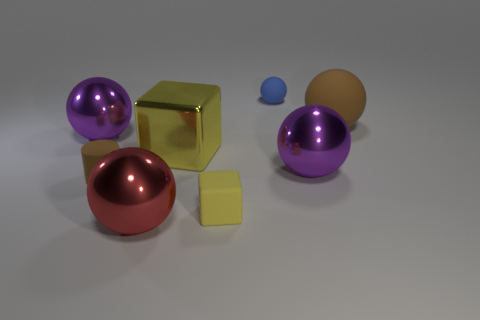Subtract 1 spheres. How many spheres are left? 4 Subtract all brown spheres. How many spheres are left? 4 Subtract all brown balls. How many balls are left? 4 Subtract all yellow balls. Subtract all gray cylinders. How many balls are left? 5 Add 2 small blue rubber blocks. How many objects exist? 10 Subtract all cubes. How many objects are left? 6 Subtract 0 purple cylinders. How many objects are left? 8 Subtract all small brown cylinders. Subtract all red shiny cubes. How many objects are left? 7 Add 6 purple objects. How many purple objects are left? 8 Add 4 tiny cyan cubes. How many tiny cyan cubes exist? 4 